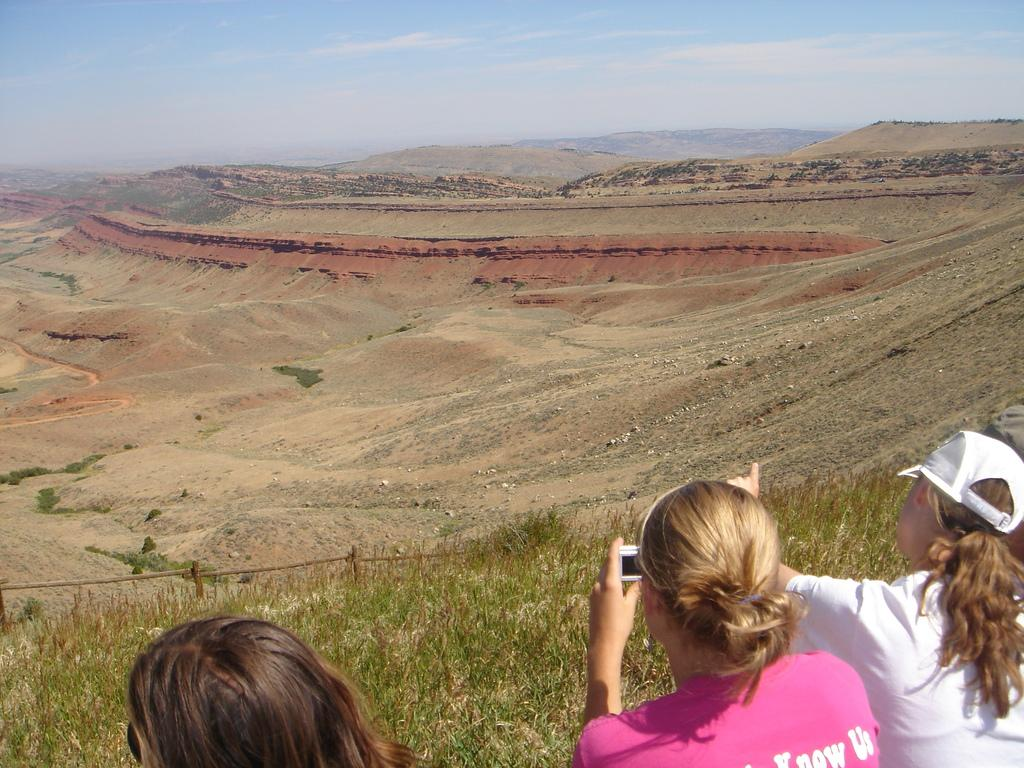What are the people in the image doing? People are standing on the ground in the image. What object is the woman holding in her hand? The woman is holding a camera in her hand. What type of surface is the ground covered with? The ground is covered with grass. What can be seen in the background of the image? There is mud on the ground in the background. What type of quiver is the woman using to hold her camera in the image? There is no quiver present in the image; the woman is simply holding the camera in her hand. What color is the drum that is being played in the image? There is no drum present in the image. 